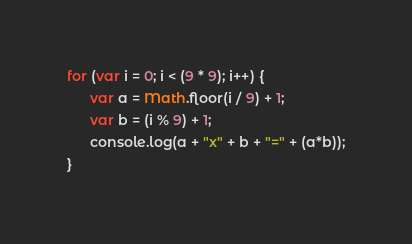Convert code to text. <code><loc_0><loc_0><loc_500><loc_500><_JavaScript_>for (var i = 0; i < (9 * 9); i++) {
      var a = Math.floor(i / 9) + 1;
      var b = (i % 9) + 1;
      console.log(a + "x" + b + "=" + (a*b));
}</code> 